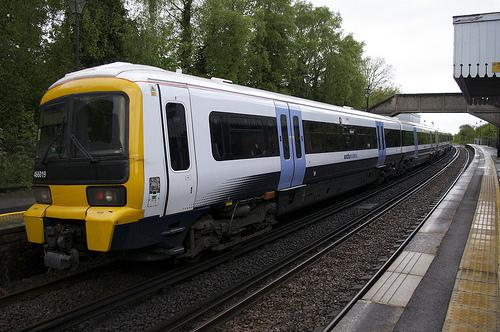Question: what color is it?
Choices:
A. Green.
B. Yellow.
C. Blue.
D. White.
Answer with the letter. Answer: D Question: how many trains?
Choices:
A. 1.
B. 2.
C. 3.
D. 4.
Answer with the letter. Answer: A Question: what is it?
Choices:
A. Bus.
B. Airplane.
C. Train.
D. Truck.
Answer with the letter. Answer: C Question: who will ride in it?
Choices:
A. Cats.
B. Dogs.
C. People.
D. Monkeys.
Answer with the letter. Answer: C Question: what is on the racks?
Choices:
A. Train.
B. Caboose.
C. Railroad Worker.
D. Dining Car.
Answer with the letter. Answer: A 